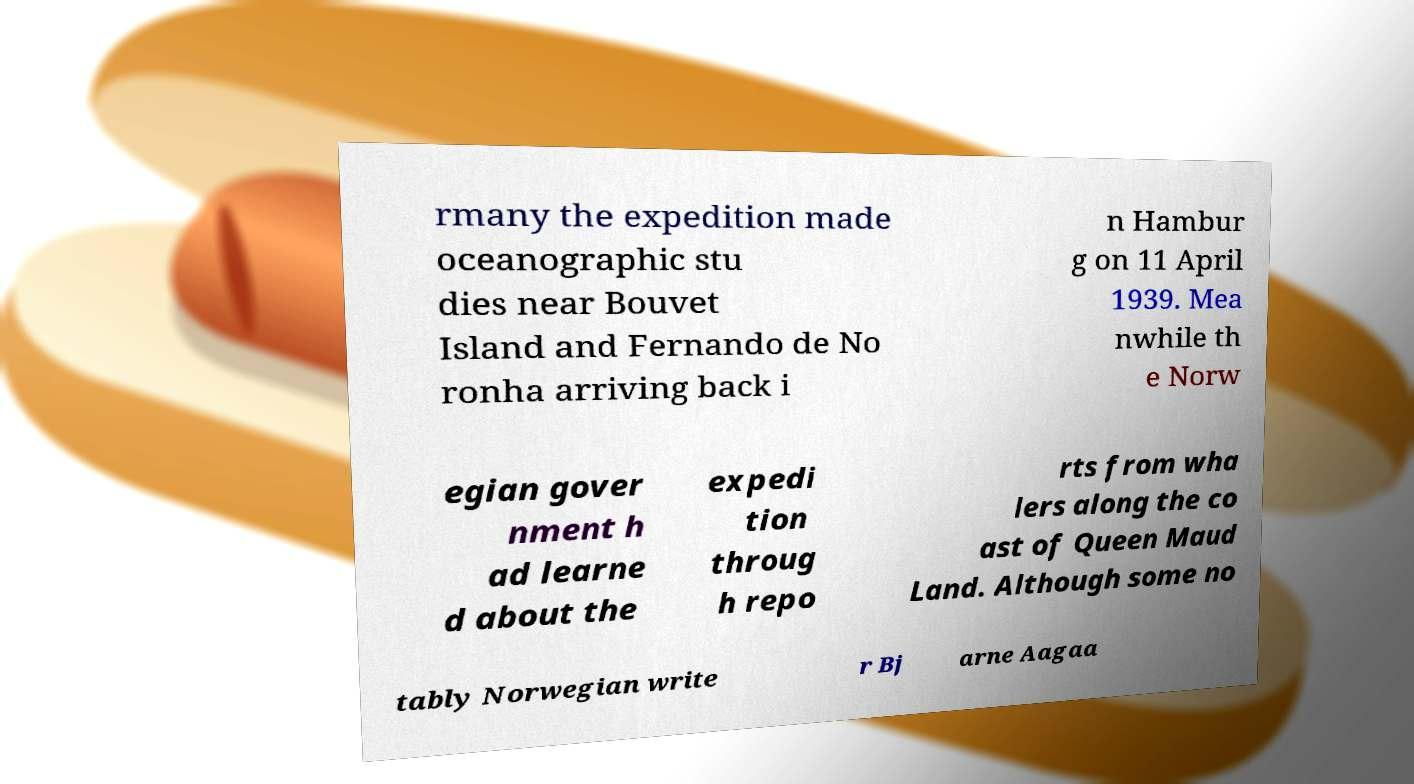Could you extract and type out the text from this image? rmany the expedition made oceanographic stu dies near Bouvet Island and Fernando de No ronha arriving back i n Hambur g on 11 April 1939. Mea nwhile th e Norw egian gover nment h ad learne d about the expedi tion throug h repo rts from wha lers along the co ast of Queen Maud Land. Although some no tably Norwegian write r Bj arne Aagaa 